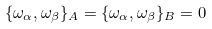Convert formula to latex. <formula><loc_0><loc_0><loc_500><loc_500>\{ \omega _ { \alpha } , \omega _ { \beta } \} _ { A } = \{ \omega _ { \alpha } , \omega _ { \beta } \} _ { B } = 0</formula> 